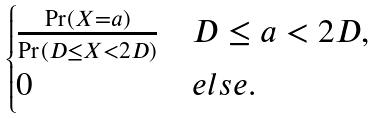<formula> <loc_0><loc_0><loc_500><loc_500>\begin{cases} \frac { \Pr ( X = a ) } { \Pr ( D \leq X < 2 D ) } & D \leq a < 2 D , \\ 0 & e l s e . \end{cases}</formula> 